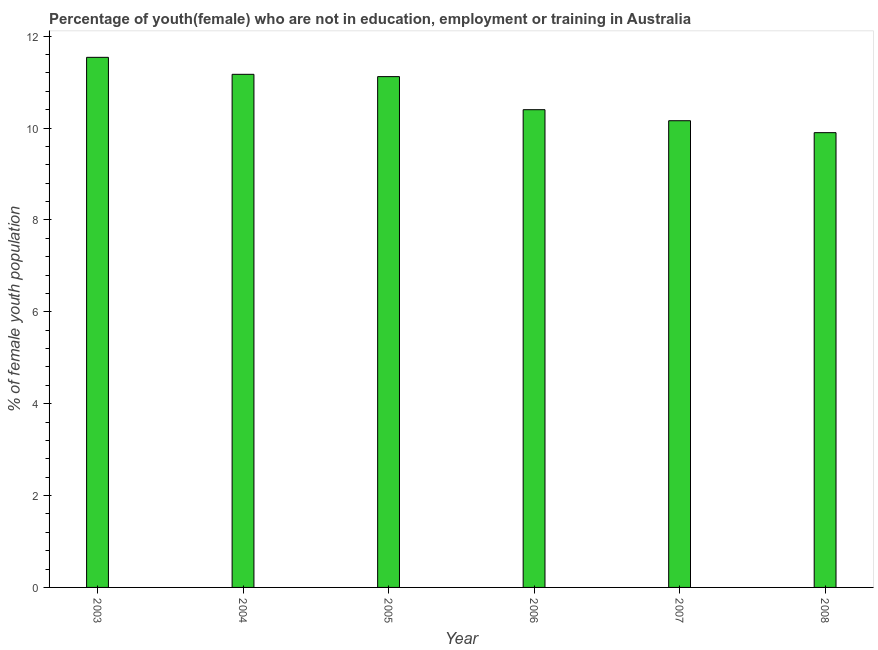Does the graph contain grids?
Your answer should be very brief. No. What is the title of the graph?
Provide a short and direct response. Percentage of youth(female) who are not in education, employment or training in Australia. What is the label or title of the X-axis?
Ensure brevity in your answer.  Year. What is the label or title of the Y-axis?
Give a very brief answer. % of female youth population. What is the unemployed female youth population in 2004?
Your answer should be very brief. 11.17. Across all years, what is the maximum unemployed female youth population?
Provide a short and direct response. 11.54. Across all years, what is the minimum unemployed female youth population?
Provide a succinct answer. 9.9. In which year was the unemployed female youth population maximum?
Make the answer very short. 2003. What is the sum of the unemployed female youth population?
Your answer should be compact. 64.29. What is the difference between the unemployed female youth population in 2004 and 2007?
Offer a very short reply. 1.01. What is the average unemployed female youth population per year?
Offer a terse response. 10.71. What is the median unemployed female youth population?
Keep it short and to the point. 10.76. In how many years, is the unemployed female youth population greater than 2 %?
Offer a terse response. 6. Do a majority of the years between 2003 and 2005 (inclusive) have unemployed female youth population greater than 4.8 %?
Give a very brief answer. Yes. What is the ratio of the unemployed female youth population in 2003 to that in 2006?
Your response must be concise. 1.11. Is the unemployed female youth population in 2003 less than that in 2006?
Provide a short and direct response. No. What is the difference between the highest and the second highest unemployed female youth population?
Offer a terse response. 0.37. What is the difference between the highest and the lowest unemployed female youth population?
Keep it short and to the point. 1.64. How many years are there in the graph?
Your answer should be compact. 6. Are the values on the major ticks of Y-axis written in scientific E-notation?
Make the answer very short. No. What is the % of female youth population in 2003?
Give a very brief answer. 11.54. What is the % of female youth population in 2004?
Your answer should be compact. 11.17. What is the % of female youth population in 2005?
Ensure brevity in your answer.  11.12. What is the % of female youth population in 2006?
Provide a succinct answer. 10.4. What is the % of female youth population in 2007?
Provide a succinct answer. 10.16. What is the % of female youth population of 2008?
Your answer should be very brief. 9.9. What is the difference between the % of female youth population in 2003 and 2004?
Your answer should be compact. 0.37. What is the difference between the % of female youth population in 2003 and 2005?
Offer a terse response. 0.42. What is the difference between the % of female youth population in 2003 and 2006?
Your answer should be very brief. 1.14. What is the difference between the % of female youth population in 2003 and 2007?
Ensure brevity in your answer.  1.38. What is the difference between the % of female youth population in 2003 and 2008?
Give a very brief answer. 1.64. What is the difference between the % of female youth population in 2004 and 2005?
Give a very brief answer. 0.05. What is the difference between the % of female youth population in 2004 and 2006?
Your answer should be very brief. 0.77. What is the difference between the % of female youth population in 2004 and 2007?
Your response must be concise. 1.01. What is the difference between the % of female youth population in 2004 and 2008?
Your response must be concise. 1.27. What is the difference between the % of female youth population in 2005 and 2006?
Your answer should be very brief. 0.72. What is the difference between the % of female youth population in 2005 and 2008?
Make the answer very short. 1.22. What is the difference between the % of female youth population in 2006 and 2007?
Give a very brief answer. 0.24. What is the difference between the % of female youth population in 2006 and 2008?
Keep it short and to the point. 0.5. What is the difference between the % of female youth population in 2007 and 2008?
Ensure brevity in your answer.  0.26. What is the ratio of the % of female youth population in 2003 to that in 2004?
Your response must be concise. 1.03. What is the ratio of the % of female youth population in 2003 to that in 2005?
Your answer should be compact. 1.04. What is the ratio of the % of female youth population in 2003 to that in 2006?
Provide a short and direct response. 1.11. What is the ratio of the % of female youth population in 2003 to that in 2007?
Your response must be concise. 1.14. What is the ratio of the % of female youth population in 2003 to that in 2008?
Provide a short and direct response. 1.17. What is the ratio of the % of female youth population in 2004 to that in 2005?
Your response must be concise. 1. What is the ratio of the % of female youth population in 2004 to that in 2006?
Offer a very short reply. 1.07. What is the ratio of the % of female youth population in 2004 to that in 2007?
Give a very brief answer. 1.1. What is the ratio of the % of female youth population in 2004 to that in 2008?
Ensure brevity in your answer.  1.13. What is the ratio of the % of female youth population in 2005 to that in 2006?
Make the answer very short. 1.07. What is the ratio of the % of female youth population in 2005 to that in 2007?
Keep it short and to the point. 1.09. What is the ratio of the % of female youth population in 2005 to that in 2008?
Give a very brief answer. 1.12. What is the ratio of the % of female youth population in 2006 to that in 2008?
Your response must be concise. 1.05. 